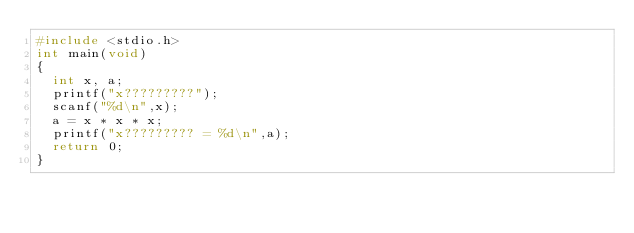<code> <loc_0><loc_0><loc_500><loc_500><_C_>#include <stdio.h>
int main(void)
{
	int x, a;
	printf("x?????????");
	scanf("%d\n",x);
	a = x * x * x;
	printf("x????????? = %d\n",a);
	return 0;
}</code> 